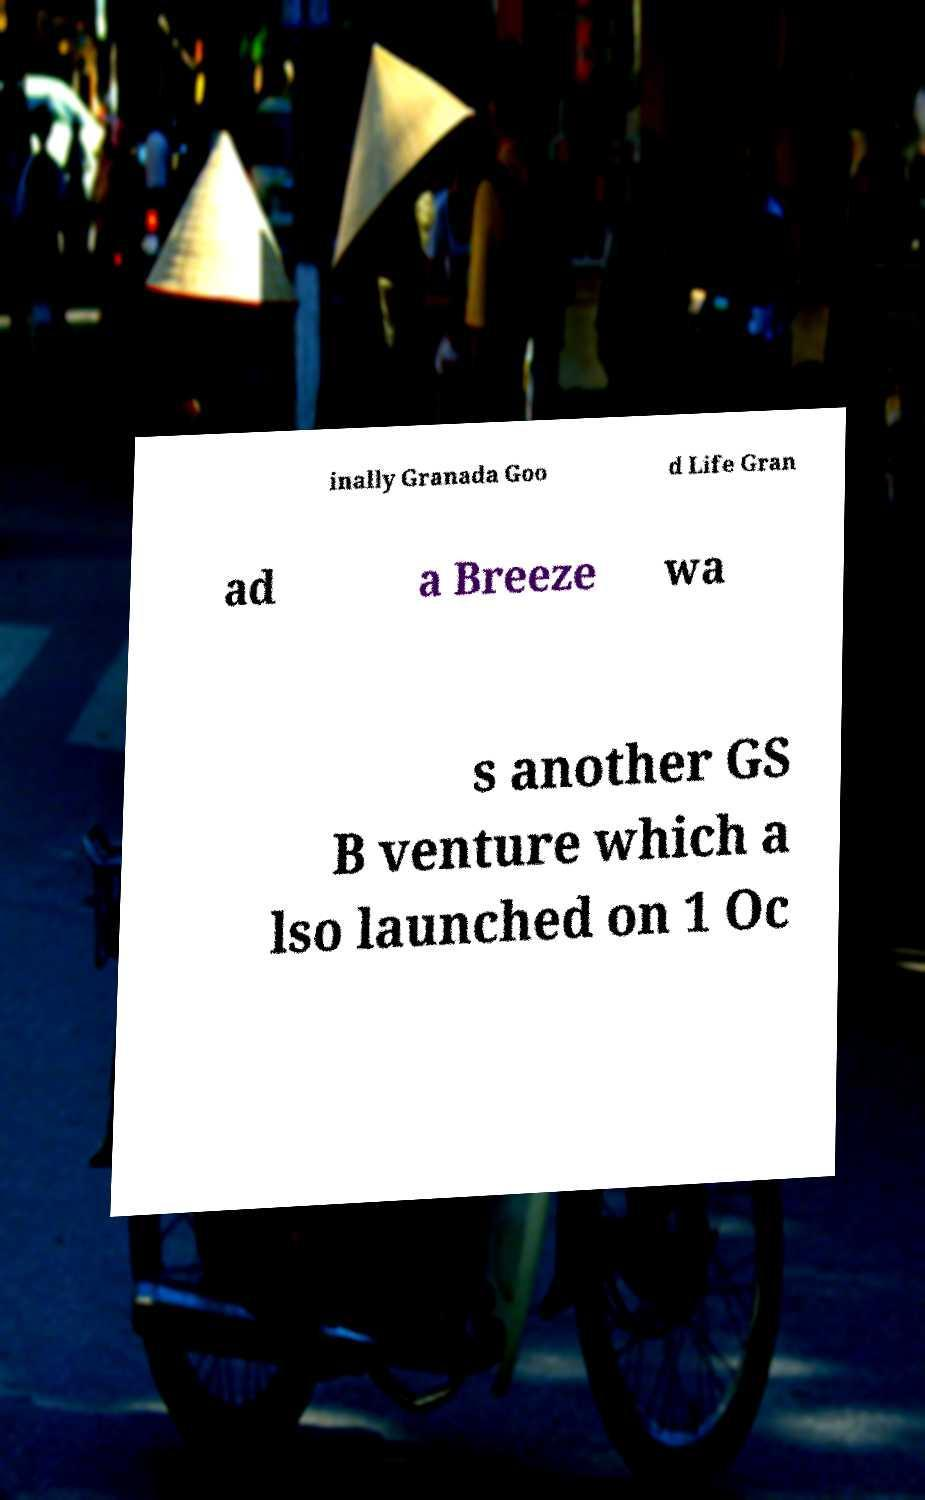Can you read and provide the text displayed in the image?This photo seems to have some interesting text. Can you extract and type it out for me? inally Granada Goo d Life Gran ad a Breeze wa s another GS B venture which a lso launched on 1 Oc 